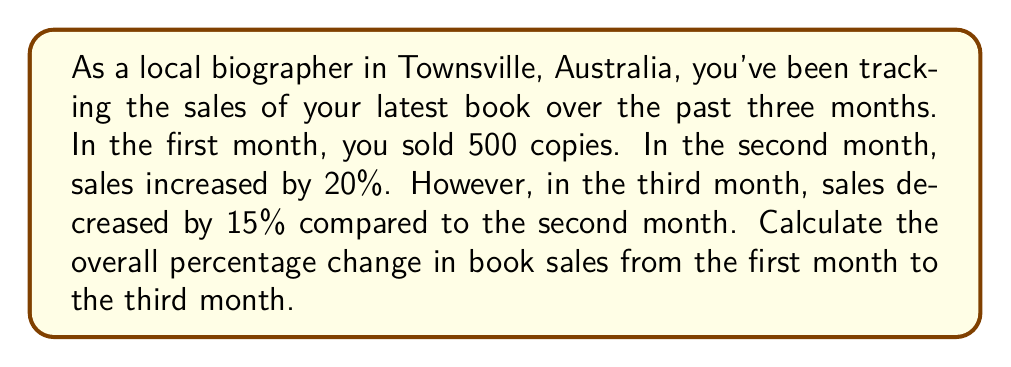Give your solution to this math problem. Let's approach this step-by-step:

1. First month sales: 500 copies

2. Second month sales:
   $500 \times (1 + 0.20) = 500 \times 1.20 = 600$ copies

3. Third month sales:
   $600 \times (1 - 0.15) = 600 \times 0.85 = 510$ copies

4. To calculate the overall percentage change, we use the formula:
   $$\text{Percentage Change} = \frac{\text{Final Value} - \text{Initial Value}}{\text{Initial Value}} \times 100\%$$

5. Plugging in our values:
   $$\text{Percentage Change} = \frac{510 - 500}{500} \times 100\%$$

6. Simplifying:
   $$\text{Percentage Change} = \frac{10}{500} \times 100\% = 0.02 \times 100\% = 2\%$$

Therefore, the overall percentage change in book sales from the first month to the third month is an increase of 2%.
Answer: 2% increase 